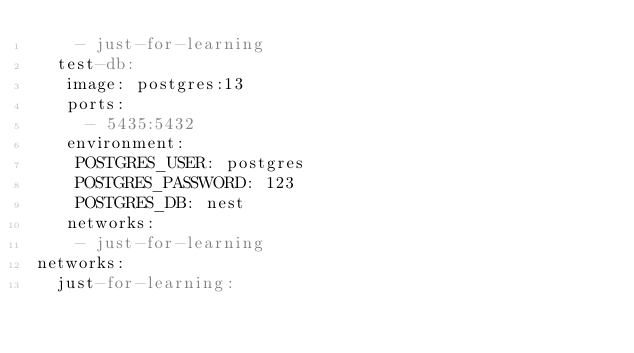Convert code to text. <code><loc_0><loc_0><loc_500><loc_500><_YAML_>    - just-for-learning
  test-db:
   image: postgres:13
   ports:
     - 5435:5432
   environment:
    POSTGRES_USER: postgres
    POSTGRES_PASSWORD: 123
    POSTGRES_DB: nest
   networks:
    - just-for-learning
networks:
  just-for-learning:
</code> 